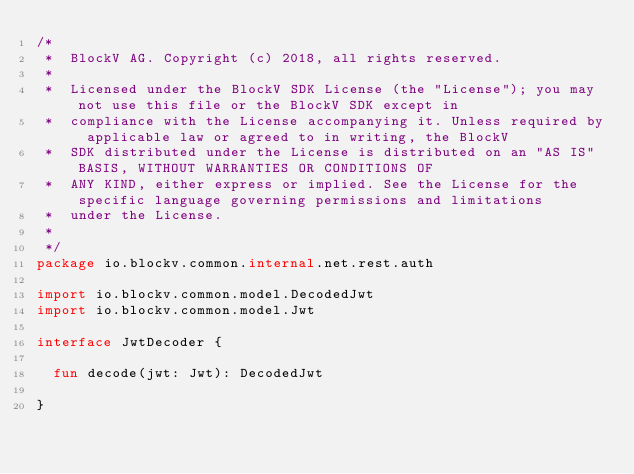<code> <loc_0><loc_0><loc_500><loc_500><_Kotlin_>/*
 *  BlockV AG. Copyright (c) 2018, all rights reserved.
 *
 *  Licensed under the BlockV SDK License (the "License"); you may not use this file or the BlockV SDK except in
 *  compliance with the License accompanying it. Unless required by applicable law or agreed to in writing, the BlockV
 *  SDK distributed under the License is distributed on an "AS IS" BASIS, WITHOUT WARRANTIES OR CONDITIONS OF
 *  ANY KIND, either express or implied. See the License for the specific language governing permissions and limitations
 *  under the License.
 *
 */
package io.blockv.common.internal.net.rest.auth

import io.blockv.common.model.DecodedJwt
import io.blockv.common.model.Jwt

interface JwtDecoder {

  fun decode(jwt: Jwt): DecodedJwt

}</code> 